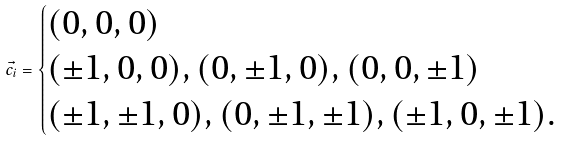Convert formula to latex. <formula><loc_0><loc_0><loc_500><loc_500>\vec { c _ { i } } = \begin{cases} ( 0 , 0 , 0 ) \\ ( \pm 1 , 0 , 0 ) , ( 0 , \pm 1 , 0 ) , ( 0 , 0 , \pm 1 ) \\ ( \pm 1 , \pm 1 , 0 ) , ( 0 , \pm 1 , \pm 1 ) , ( \pm 1 , 0 , \pm 1 ) . \end{cases}</formula> 